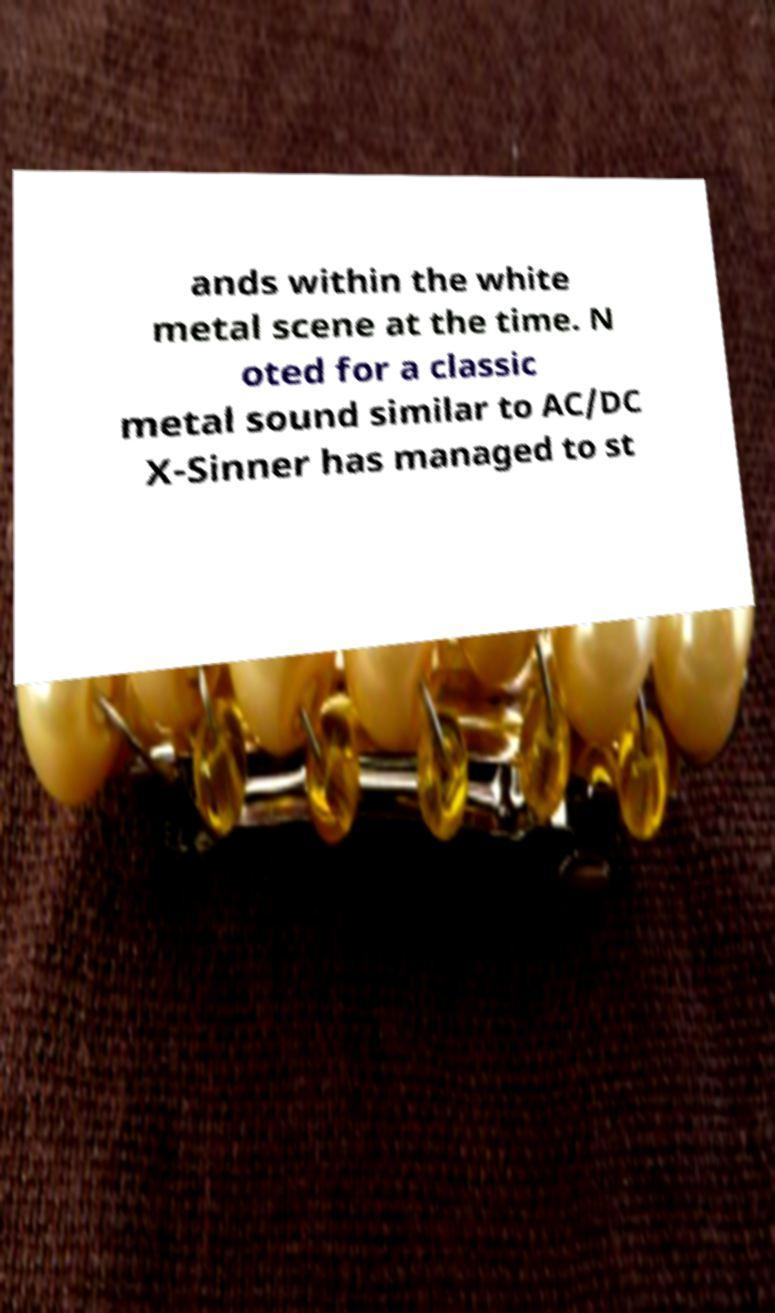Please read and relay the text visible in this image. What does it say? ands within the white metal scene at the time. N oted for a classic metal sound similar to AC/DC X-Sinner has managed to st 